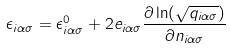<formula> <loc_0><loc_0><loc_500><loc_500>\epsilon _ { i \alpha \sigma } = \epsilon ^ { 0 } _ { i \alpha \sigma } + 2 e _ { i \alpha \sigma } \frac { \partial \ln ( \sqrt { q _ { i \alpha \sigma } } ) } { \partial n _ { i \alpha \sigma } }</formula> 